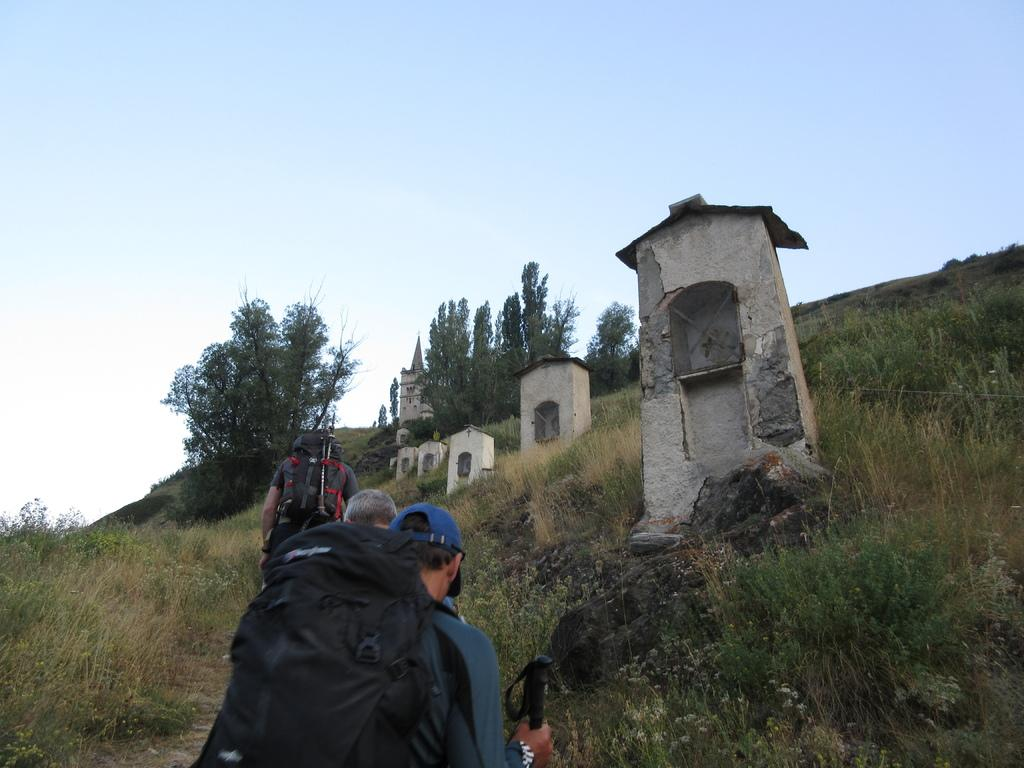What can be seen in the background of the image? The sky is visible in the background of the image. What architectural features are present in the image? There are pillars and a castle in the image. What type of vegetation is present in the image? There are trees and plants in the image. Who is present in the image? There are people in the image. What are some specific details about the people in the image? There are men wearing backpacks and men wearing caps in the image. What type of cheese is being used to promote peace in the image? There is no cheese present in the image, nor is there any reference to promoting peace. 